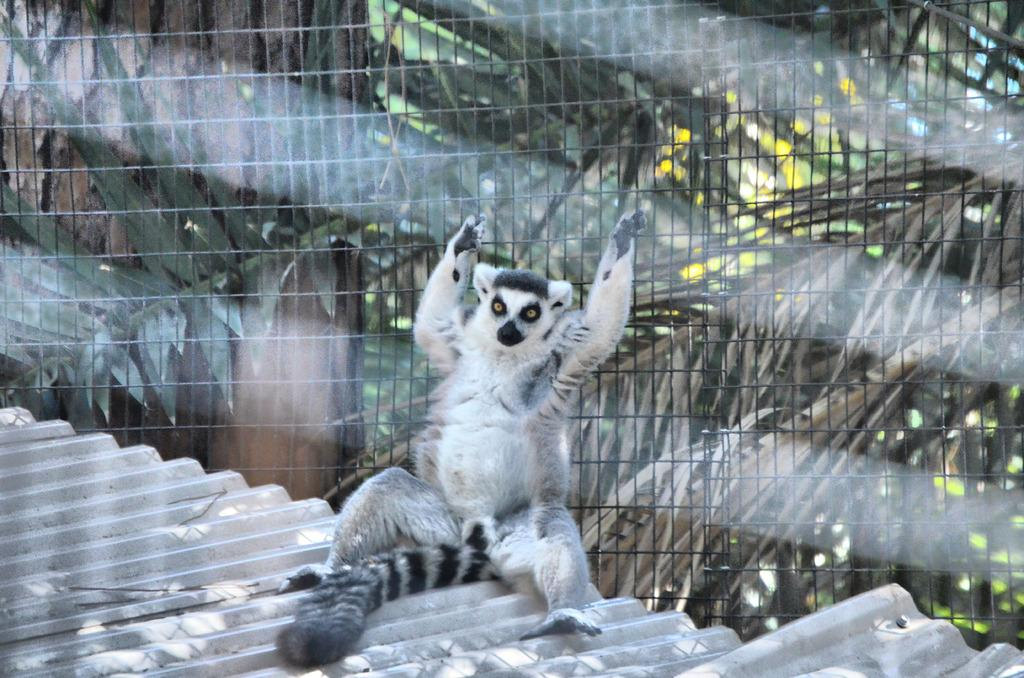What is on the roof in the image? There is an animal on the roof in the image. What is the animal holding? The animal is holding fencing. What can be seen in the background of the image? There are trees in the background of the image. How many brothers does the animal on the roof have in the image? There is no information about the animal's family or siblings in the image, so it cannot be determined. 